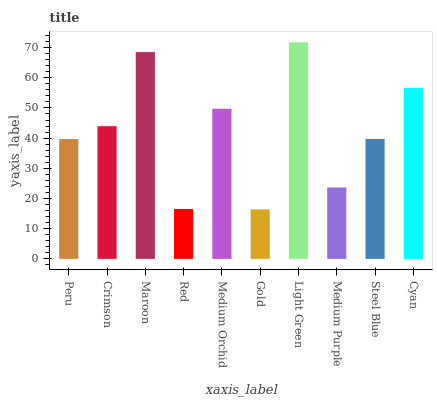Is Gold the minimum?
Answer yes or no. Yes. Is Light Green the maximum?
Answer yes or no. Yes. Is Crimson the minimum?
Answer yes or no. No. Is Crimson the maximum?
Answer yes or no. No. Is Crimson greater than Peru?
Answer yes or no. Yes. Is Peru less than Crimson?
Answer yes or no. Yes. Is Peru greater than Crimson?
Answer yes or no. No. Is Crimson less than Peru?
Answer yes or no. No. Is Crimson the high median?
Answer yes or no. Yes. Is Steel Blue the low median?
Answer yes or no. Yes. Is Maroon the high median?
Answer yes or no. No. Is Medium Orchid the low median?
Answer yes or no. No. 